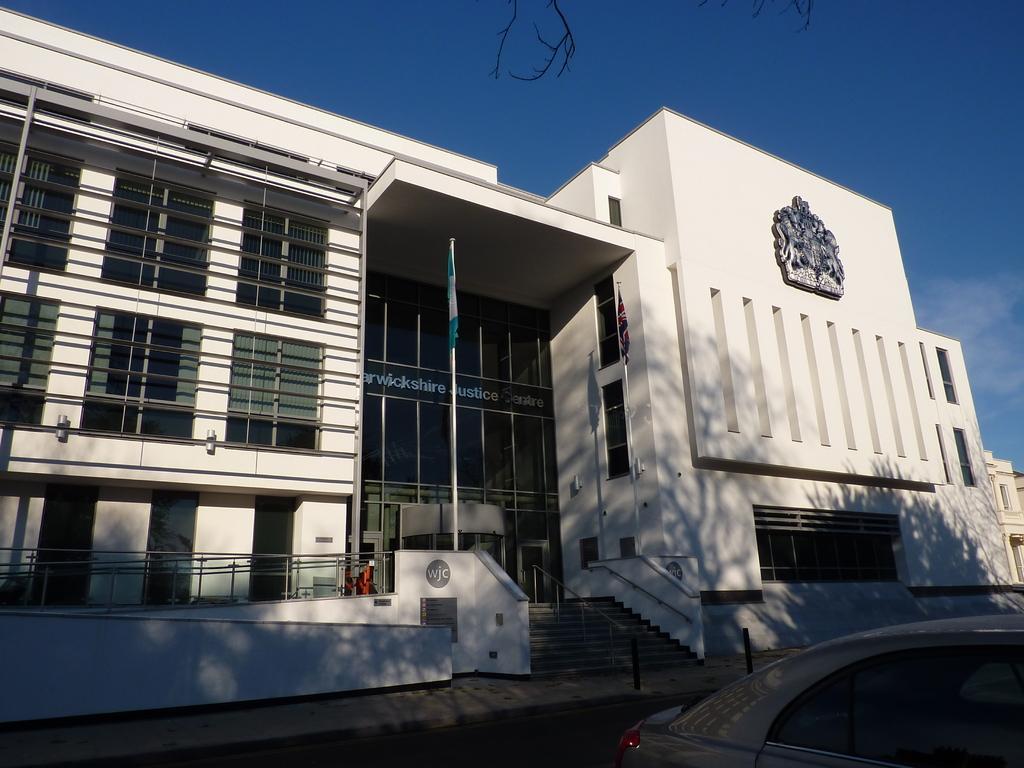In one or two sentences, can you explain what this image depicts? In this picture we can see a vehicle on the path and behind the vehicle there are buildings and a sky. 